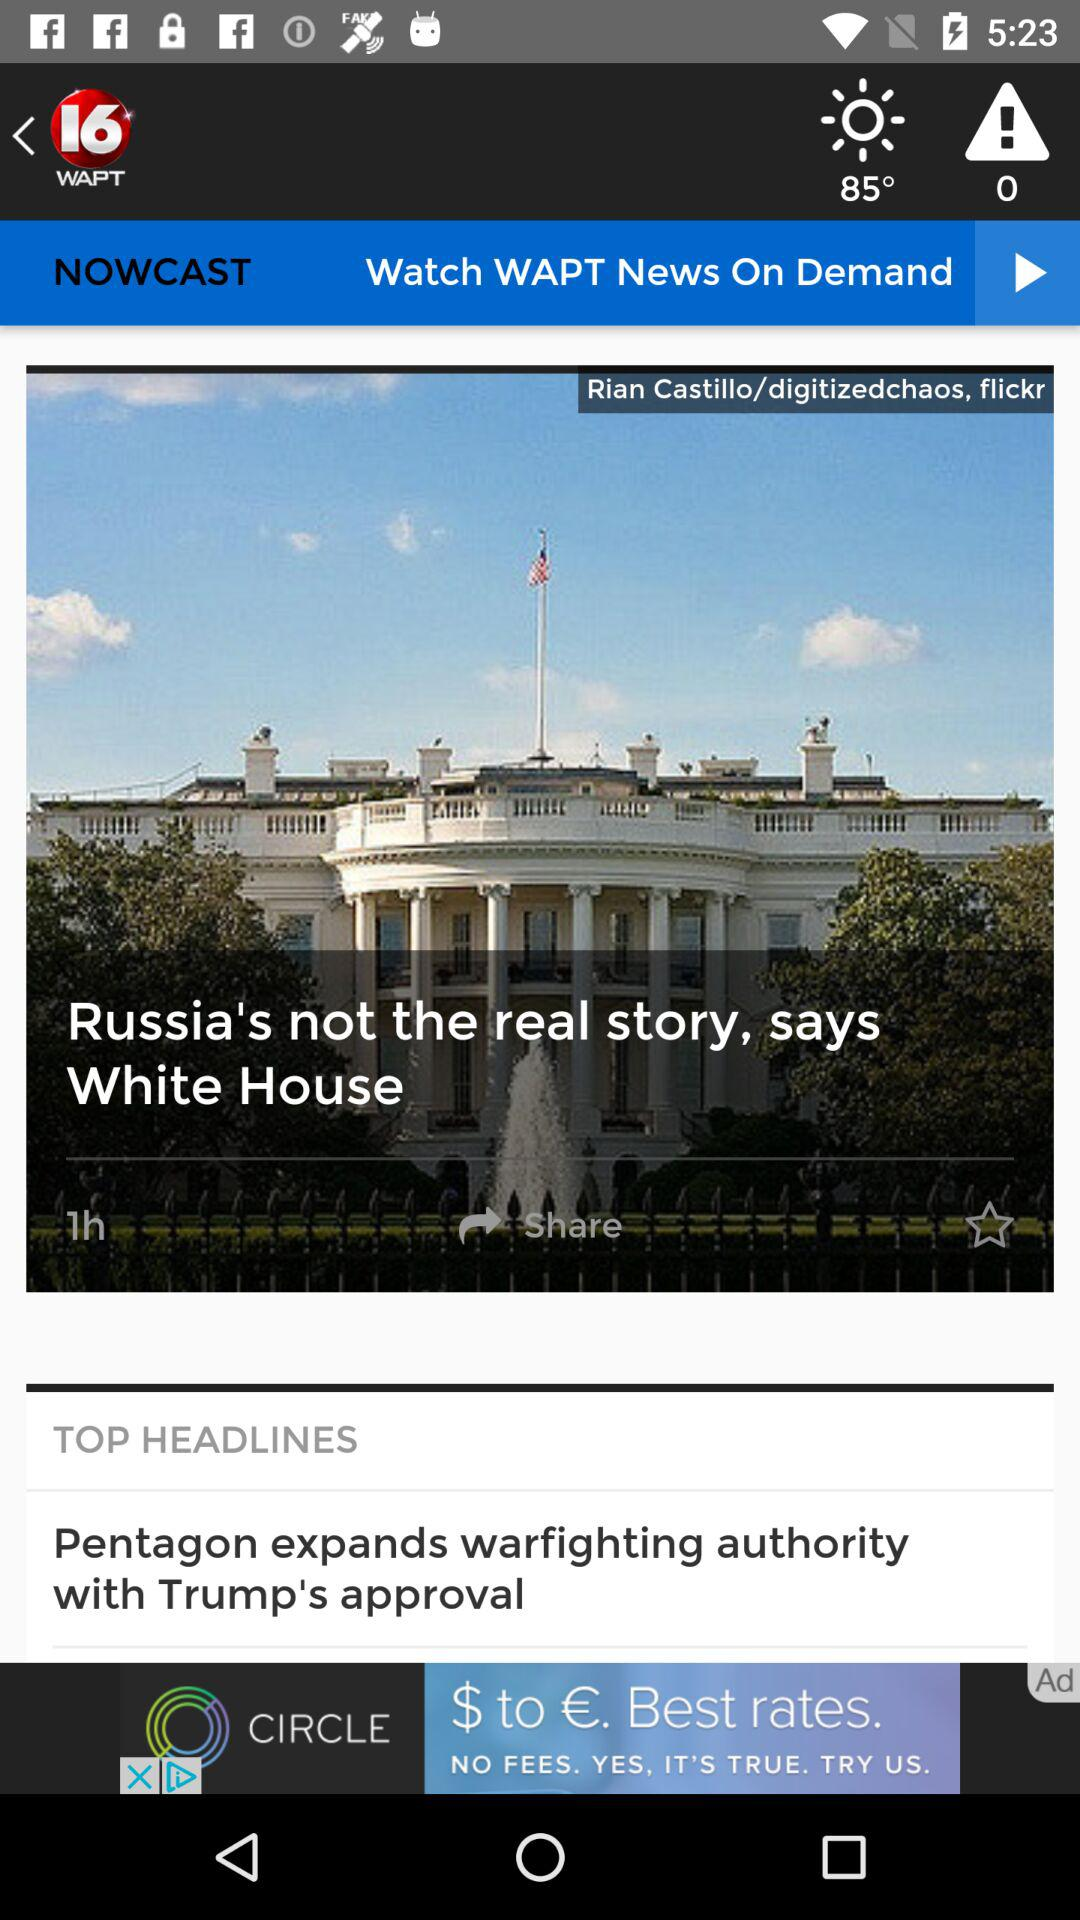On what day was "Russia's not the real story, says White House" published?
When the provided information is insufficient, respond with <no answer>. <no answer> 